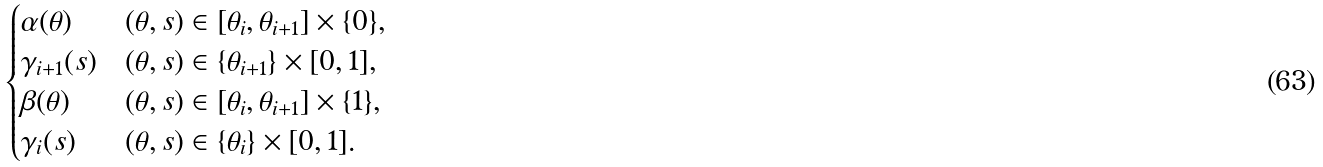Convert formula to latex. <formula><loc_0><loc_0><loc_500><loc_500>\begin{cases} \alpha ( \theta ) & ( \theta , s ) \in [ \theta _ { i } , \theta _ { i + 1 } ] \times \{ 0 \} , \\ \gamma _ { i + 1 } ( s ) & ( \theta , s ) \in \{ \theta _ { i + 1 } \} \times [ 0 , 1 ] , \\ \beta ( \theta ) & ( \theta , s ) \in [ \theta _ { i } , \theta _ { i + 1 } ] \times \{ 1 \} , \\ \gamma _ { i } ( s ) & ( \theta , s ) \in \{ \theta _ { i } \} \times [ 0 , 1 ] . \\ \end{cases}</formula> 